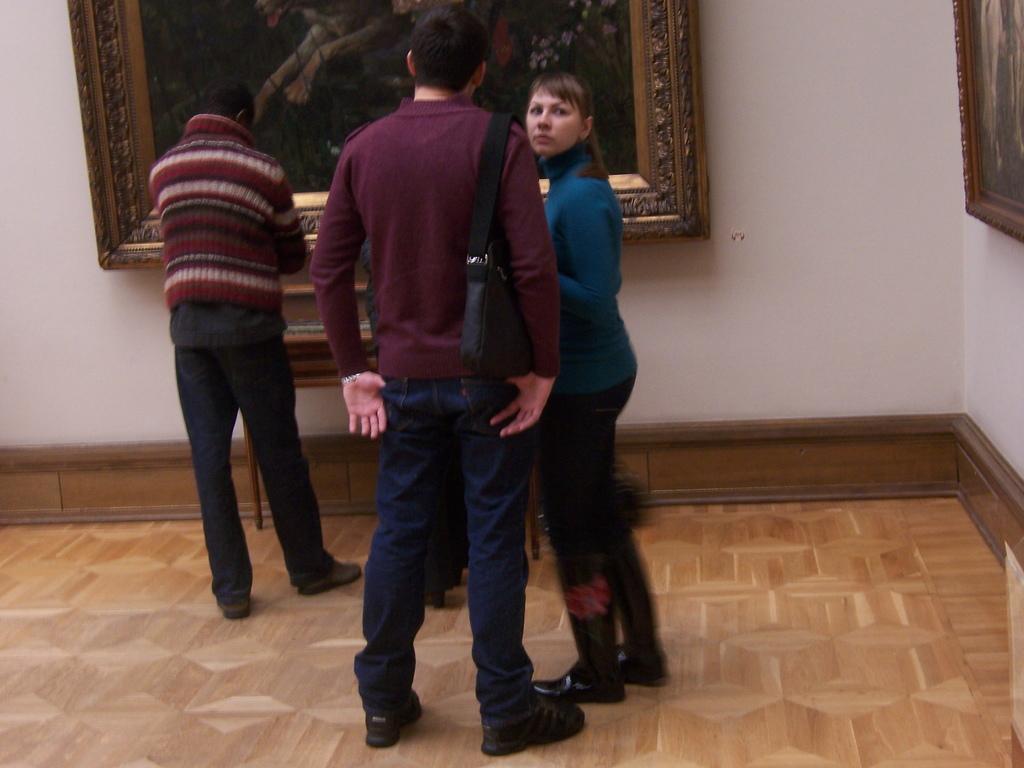Could you give a brief overview of what you see in this image? This picture is clicked inside the room. In the center we can see the group of persons standing on the floor and we can see a sling bag and the picture frames hanging on the wall and we can see some other objects in the background. 